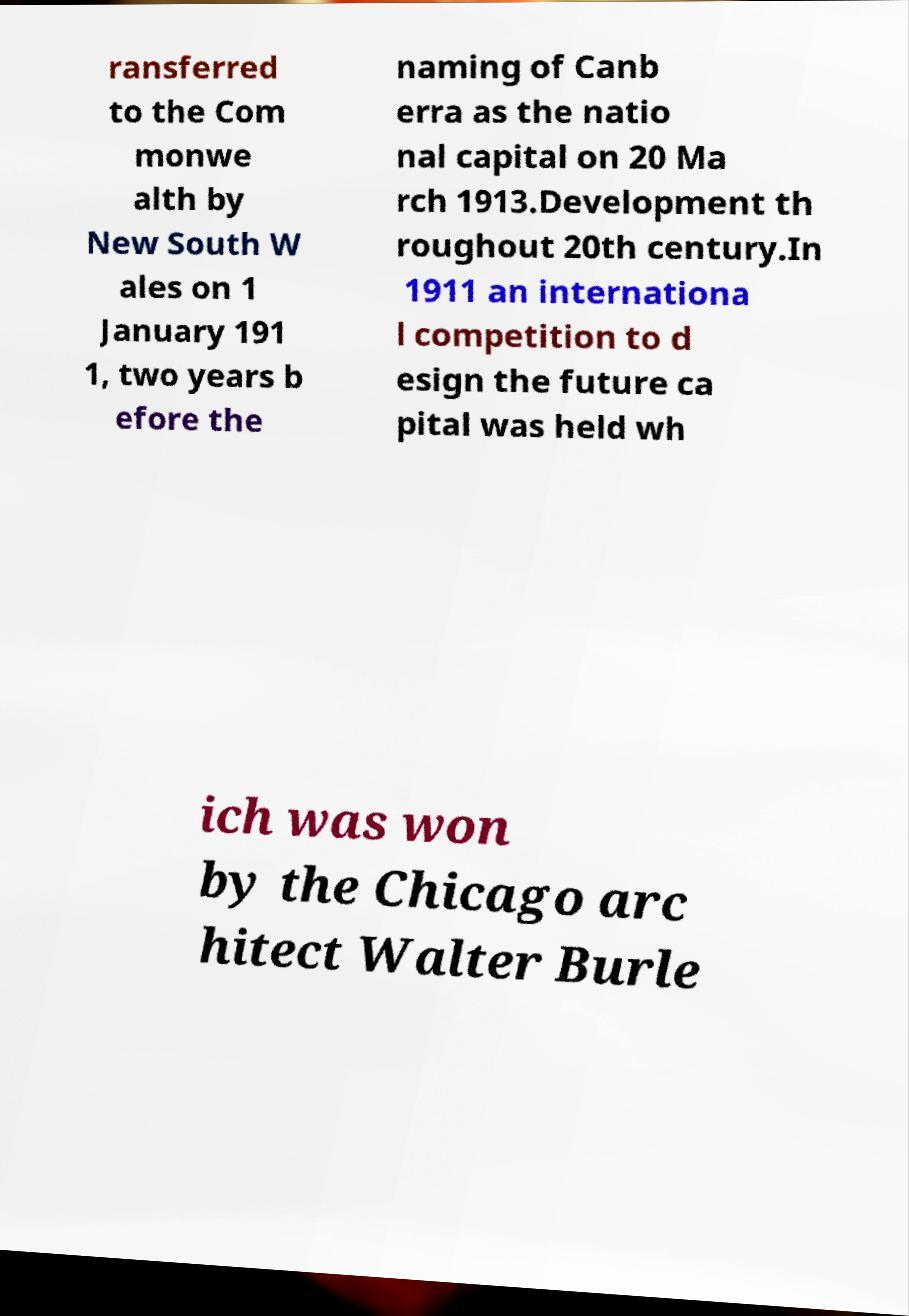There's text embedded in this image that I need extracted. Can you transcribe it verbatim? ransferred to the Com monwe alth by New South W ales on 1 January 191 1, two years b efore the naming of Canb erra as the natio nal capital on 20 Ma rch 1913.Development th roughout 20th century.In 1911 an internationa l competition to d esign the future ca pital was held wh ich was won by the Chicago arc hitect Walter Burle 